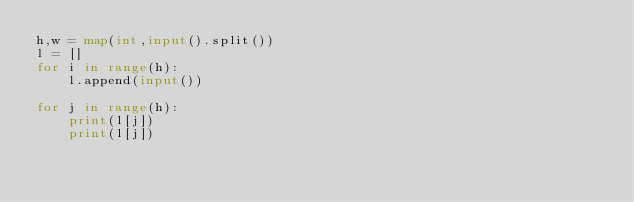<code> <loc_0><loc_0><loc_500><loc_500><_Python_>h,w = map(int,input().split())
l = []
for i in range(h):
    l.append(input())

for j in range(h):
    print(l[j])
    print(l[j])
    </code> 